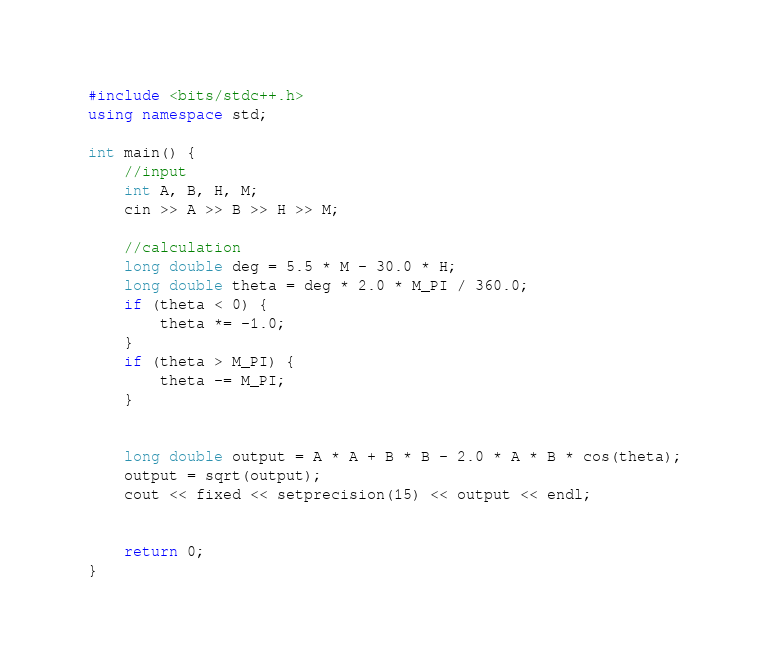Convert code to text. <code><loc_0><loc_0><loc_500><loc_500><_C++_>#include <bits/stdc++.h>
using namespace std;

int main() {
	//input
	int A, B, H, M;
	cin >> A >> B >> H >> M;

	//calculation
	long double deg = 5.5 * M - 30.0 * H;
	long double theta = deg * 2.0 * M_PI / 360.0;
	if (theta < 0) {
		theta *= -1.0;
	}
	if (theta > M_PI) {
		theta -= M_PI;
	}


	long double output = A * A + B * B - 2.0 * A * B * cos(theta);
	output = sqrt(output);
	cout << fixed << setprecision(15) << output << endl;


	return 0;
}
</code> 